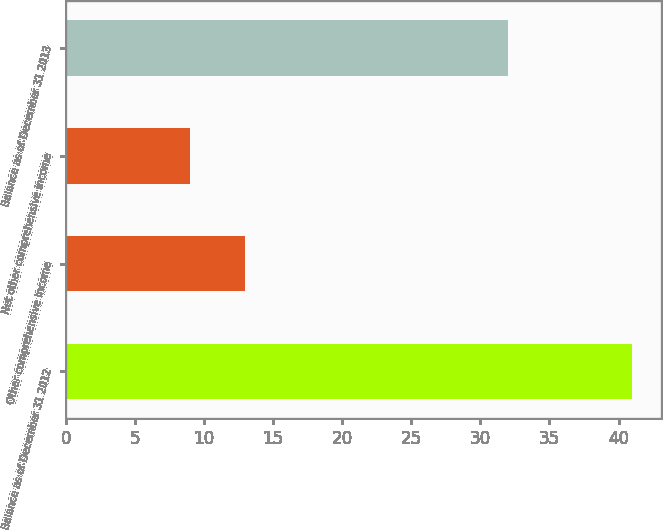<chart> <loc_0><loc_0><loc_500><loc_500><bar_chart><fcel>Balance as of December 31 2012<fcel>Other comprehensive income<fcel>Net other comprehensive income<fcel>Balance as of December 31 2013<nl><fcel>41<fcel>13<fcel>9<fcel>32<nl></chart> 